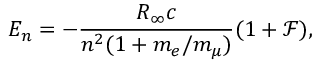Convert formula to latex. <formula><loc_0><loc_0><loc_500><loc_500>E _ { n } = - \frac { R _ { \infty } c } { n ^ { 2 } ( 1 + m _ { e } / m _ { \mu } ) } ( 1 + \mathcal { F } ) ,</formula> 